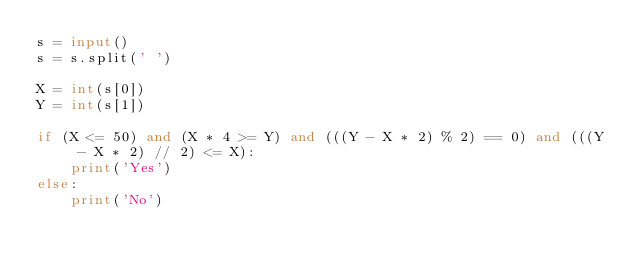<code> <loc_0><loc_0><loc_500><loc_500><_Python_>s = input()
s = s.split(' ')

X = int(s[0])
Y = int(s[1])

if (X <= 50) and (X * 4 >= Y) and (((Y - X * 2) % 2) == 0) and (((Y - X * 2) // 2) <= X):
    print('Yes')
else:
    print('No')
</code> 